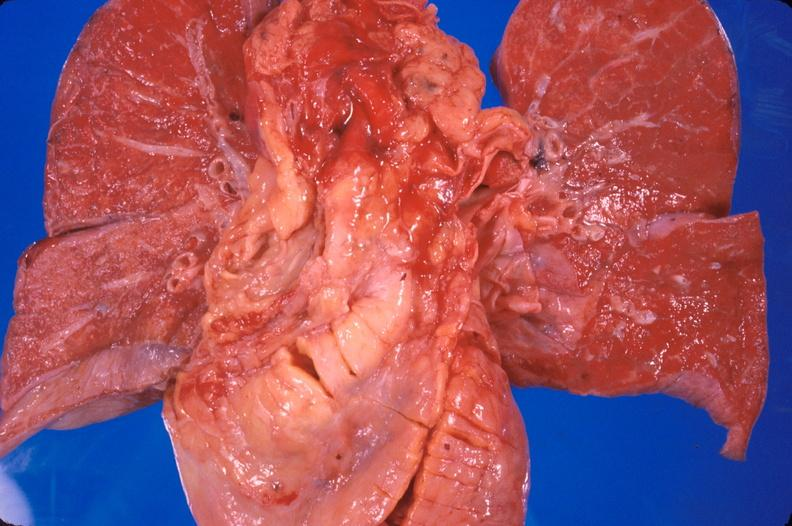s spina bifida present?
Answer the question using a single word or phrase. No 